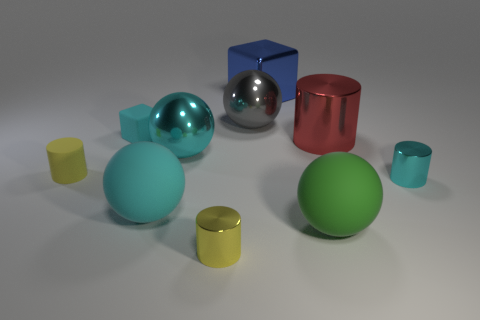Subtract all red cylinders. How many cylinders are left? 3 Subtract all brown cylinders. How many cyan spheres are left? 2 Subtract all cyan spheres. How many spheres are left? 2 Subtract all blocks. How many objects are left? 8 Add 5 cyan cylinders. How many cyan cylinders are left? 6 Add 6 small matte blocks. How many small matte blocks exist? 7 Subtract 0 brown spheres. How many objects are left? 10 Subtract all green cubes. Subtract all brown cylinders. How many cubes are left? 2 Subtract all tiny purple rubber things. Subtract all cyan rubber cubes. How many objects are left? 9 